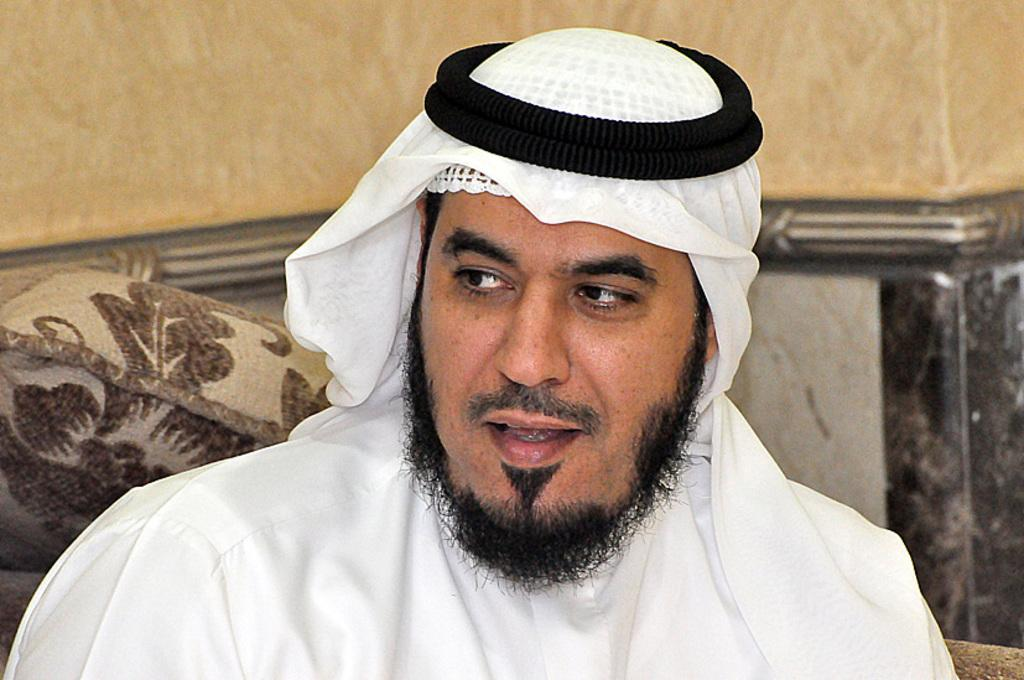Who is present in the image? There is a man in the image. What is on the man's head? The man has a cloth on his head, and there is a black band on his head. What can be seen in the background of the image? There is a pillow and a wall in the background of the image. What type of flame can be seen on the fork in the image? There is no fork or flame present in the image. How many boats are visible in the image? There are no boats visible in the image. 